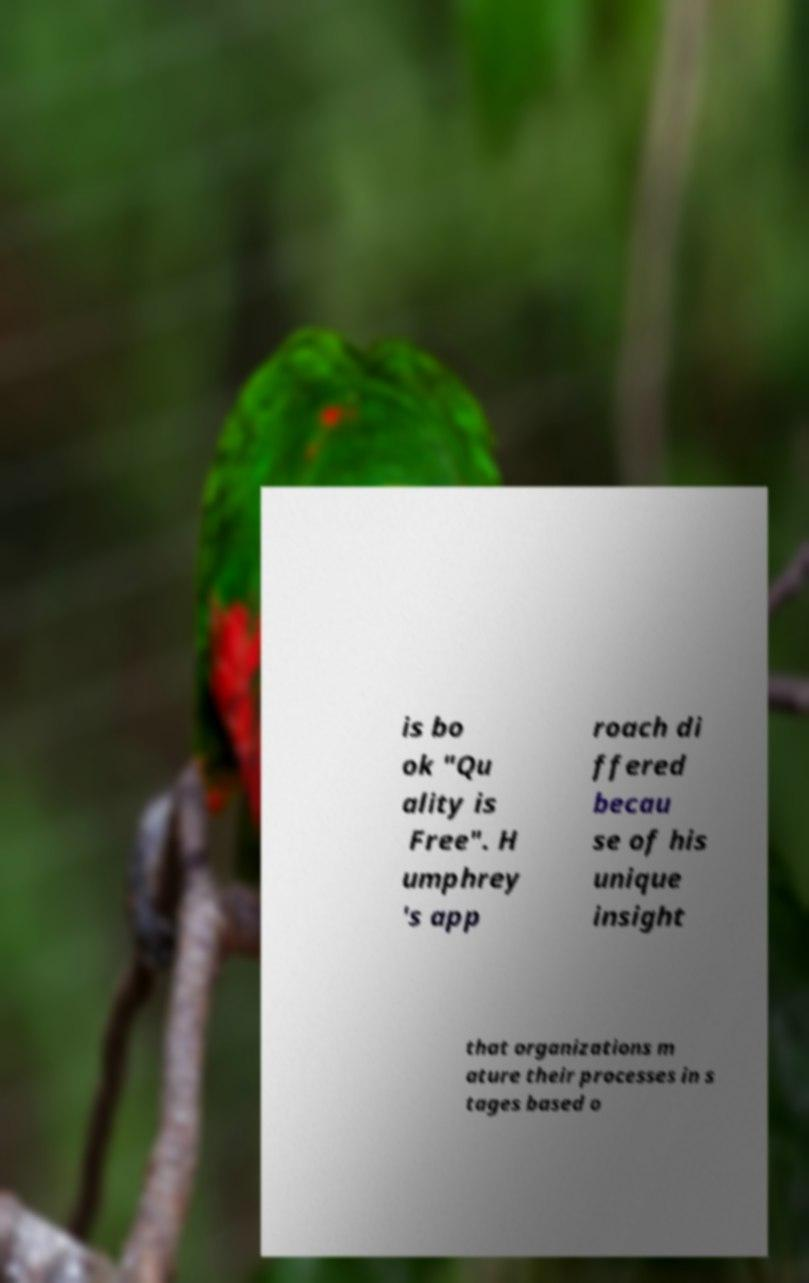What messages or text are displayed in this image? I need them in a readable, typed format. is bo ok "Qu ality is Free". H umphrey 's app roach di ffered becau se of his unique insight that organizations m ature their processes in s tages based o 